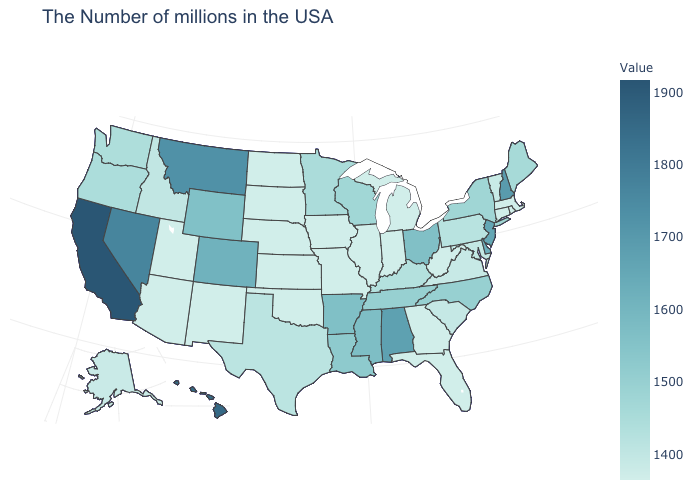Among the states that border New York , which have the highest value?
Be succinct. New Jersey. Does Illinois have the lowest value in the MidWest?
Write a very short answer. Yes. Does Wyoming have a lower value than New Jersey?
Answer briefly. Yes. Which states have the highest value in the USA?
Be succinct. California. Among the states that border Connecticut , does Rhode Island have the lowest value?
Be succinct. Yes. Does Tennessee have a lower value than Georgia?
Short answer required. No. Among the states that border Texas , which have the lowest value?
Concise answer only. Oklahoma, New Mexico. Among the states that border Tennessee , does Alabama have the lowest value?
Be succinct. No. 